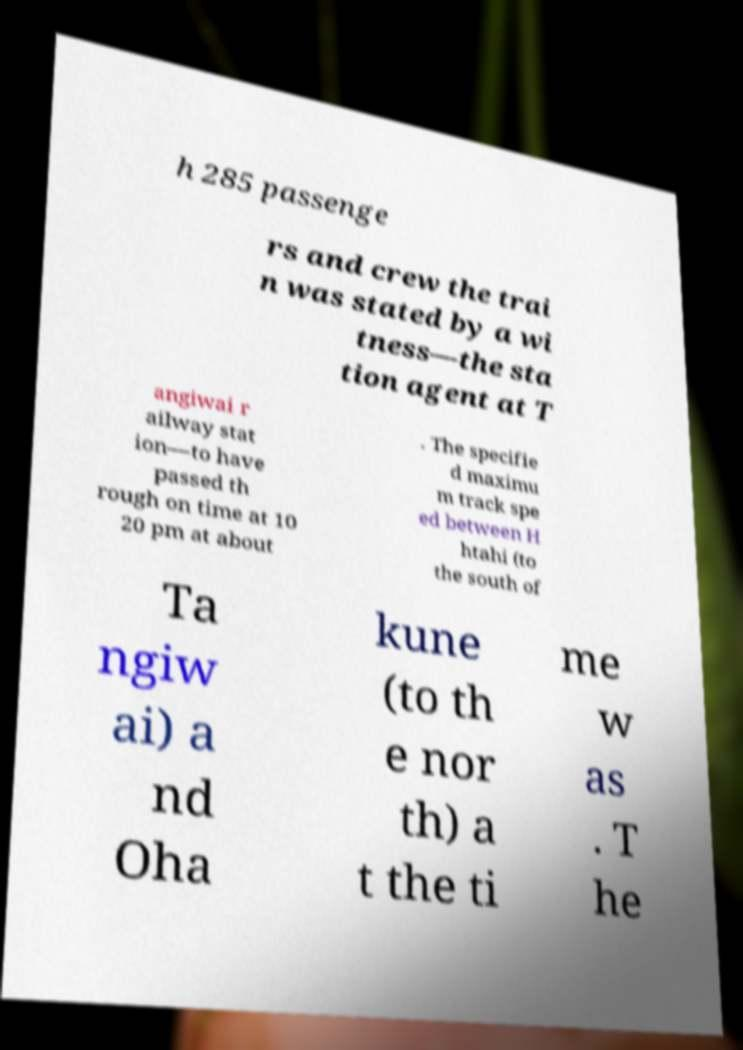Can you read and provide the text displayed in the image?This photo seems to have some interesting text. Can you extract and type it out for me? h 285 passenge rs and crew the trai n was stated by a wi tness—the sta tion agent at T angiwai r ailway stat ion—to have passed th rough on time at 10 20 pm at about . The specifie d maximu m track spe ed between H htahi (to the south of Ta ngiw ai) a nd Oha kune (to th e nor th) a t the ti me w as . T he 